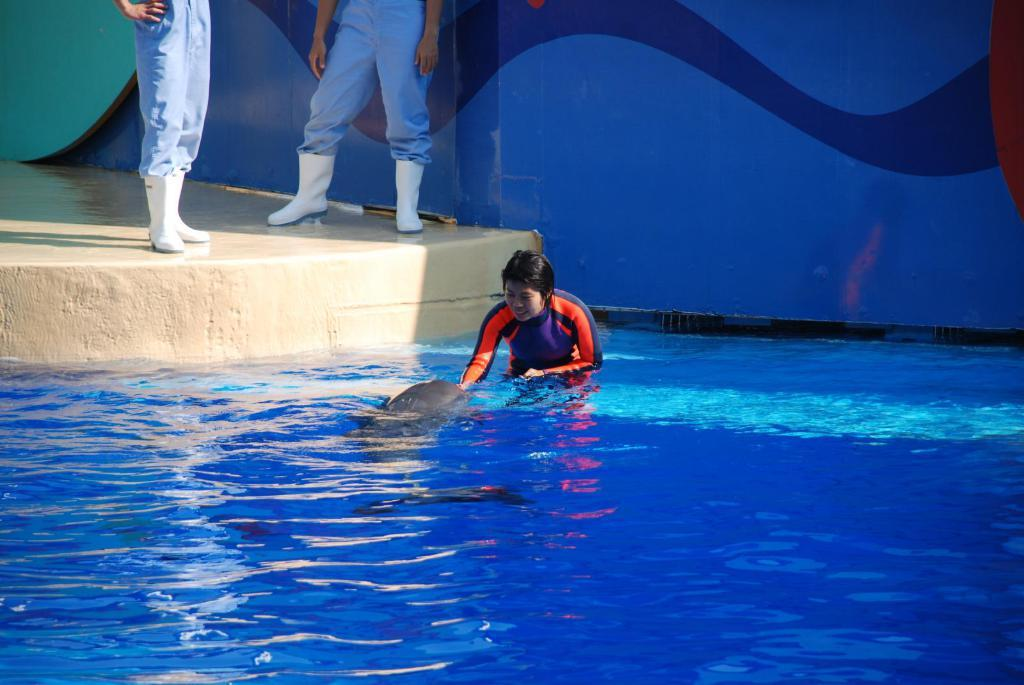Who or what is present in the image? There is a person and a whale in the water in the image. What is the primary setting of the image? The image features water, suggesting a beach or ocean setting. What can be seen in the background of the image? There is a wall in the background of the image, and other people are visible on the floor in the background. What type of structure is the whale using to change the substance in the image? There is no structure, whale, or substance mentioned or depicted in the image. 